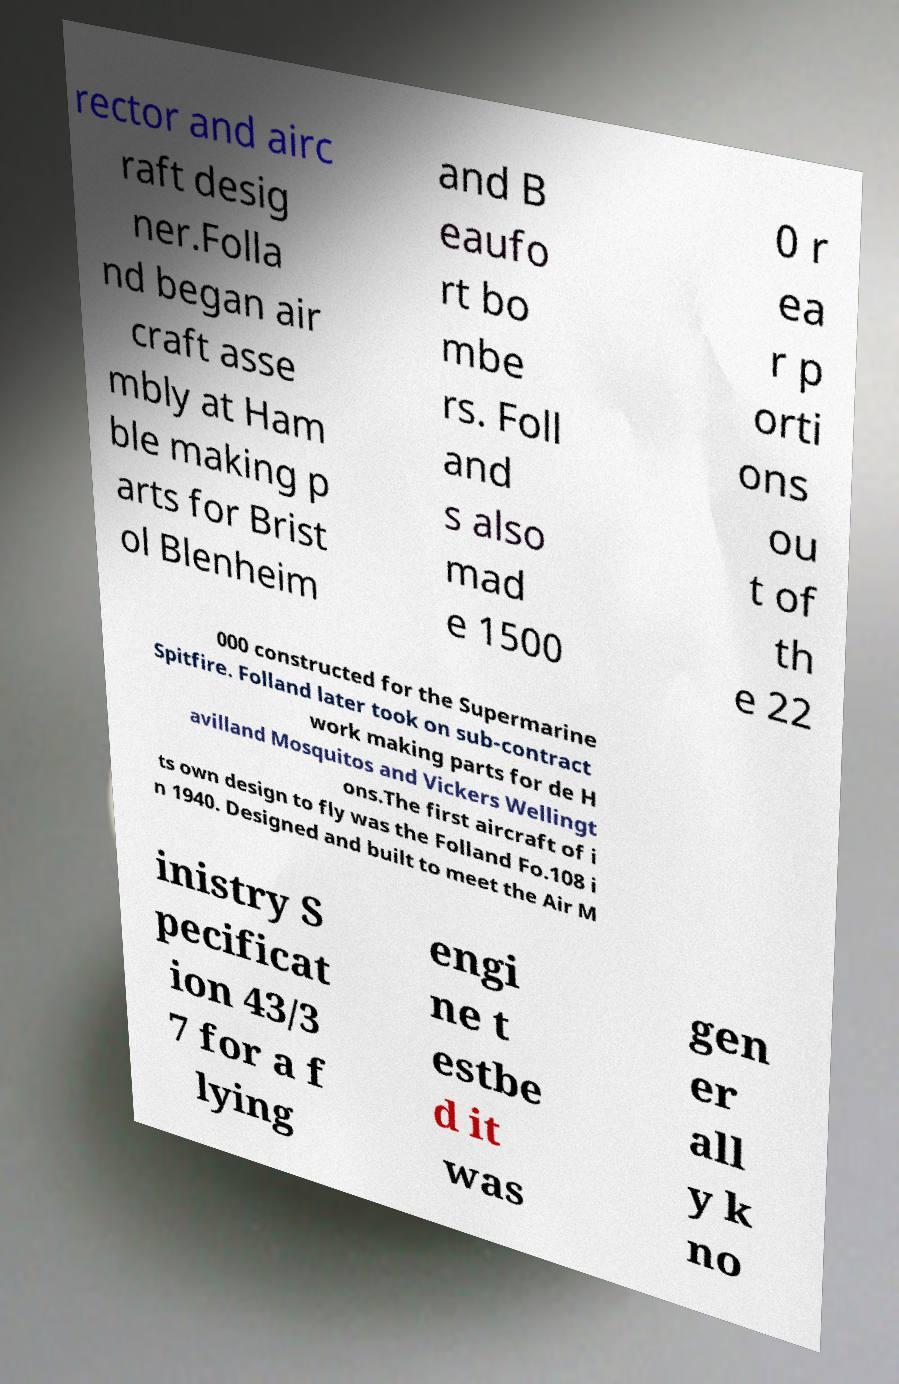I need the written content from this picture converted into text. Can you do that? rector and airc raft desig ner.Folla nd began air craft asse mbly at Ham ble making p arts for Brist ol Blenheim and B eaufo rt bo mbe rs. Foll and s also mad e 1500 0 r ea r p orti ons ou t of th e 22 000 constructed for the Supermarine Spitfire. Folland later took on sub-contract work making parts for de H avilland Mosquitos and Vickers Wellingt ons.The first aircraft of i ts own design to fly was the Folland Fo.108 i n 1940. Designed and built to meet the Air M inistry S pecificat ion 43/3 7 for a f lying engi ne t estbe d it was gen er all y k no 